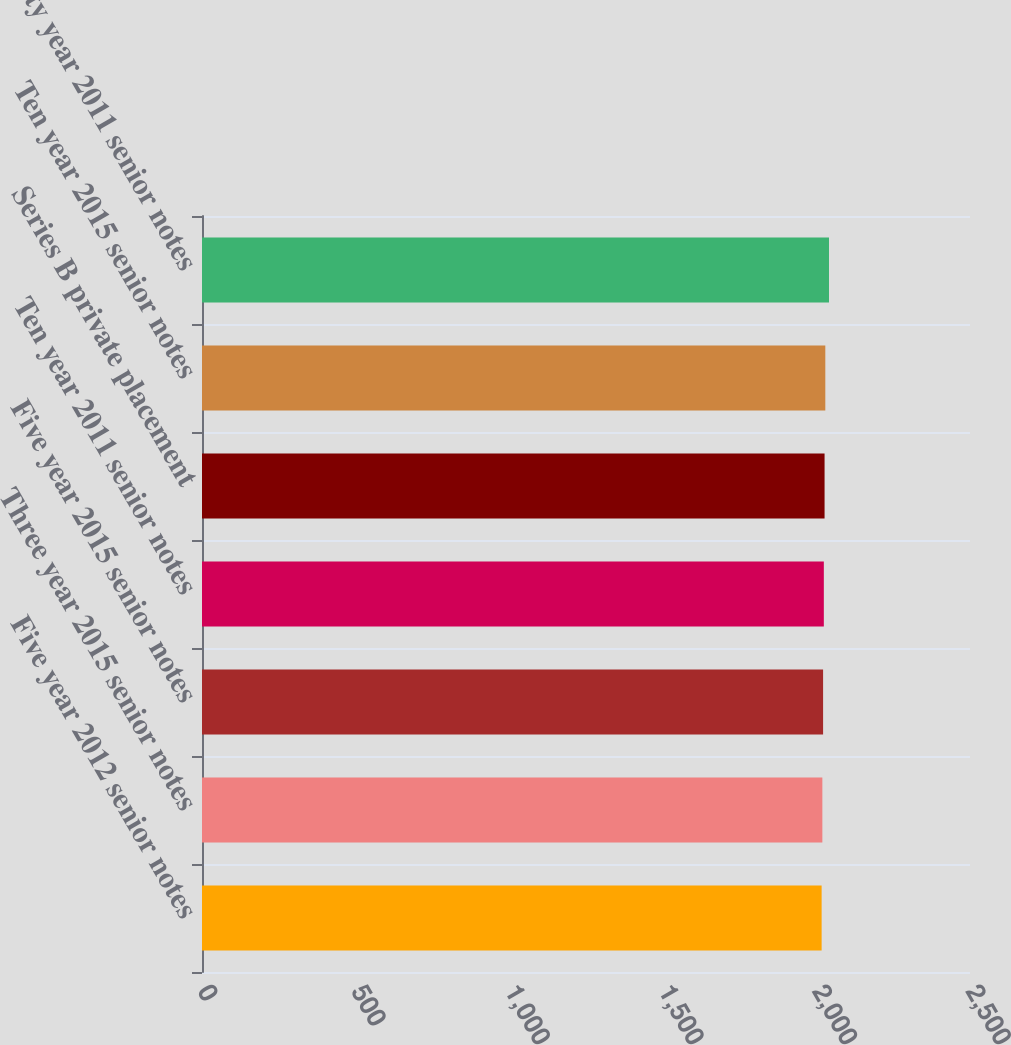Convert chart to OTSL. <chart><loc_0><loc_0><loc_500><loc_500><bar_chart><fcel>Five year 2012 senior notes<fcel>Three year 2015 senior notes<fcel>Five year 2015 senior notes<fcel>Ten year 2011 senior notes<fcel>Series B private placement<fcel>Ten year 2015 senior notes<fcel>Thirty year 2011 senior notes<nl><fcel>2017<fcel>2019.4<fcel>2021.8<fcel>2024.2<fcel>2026.6<fcel>2029<fcel>2041<nl></chart> 